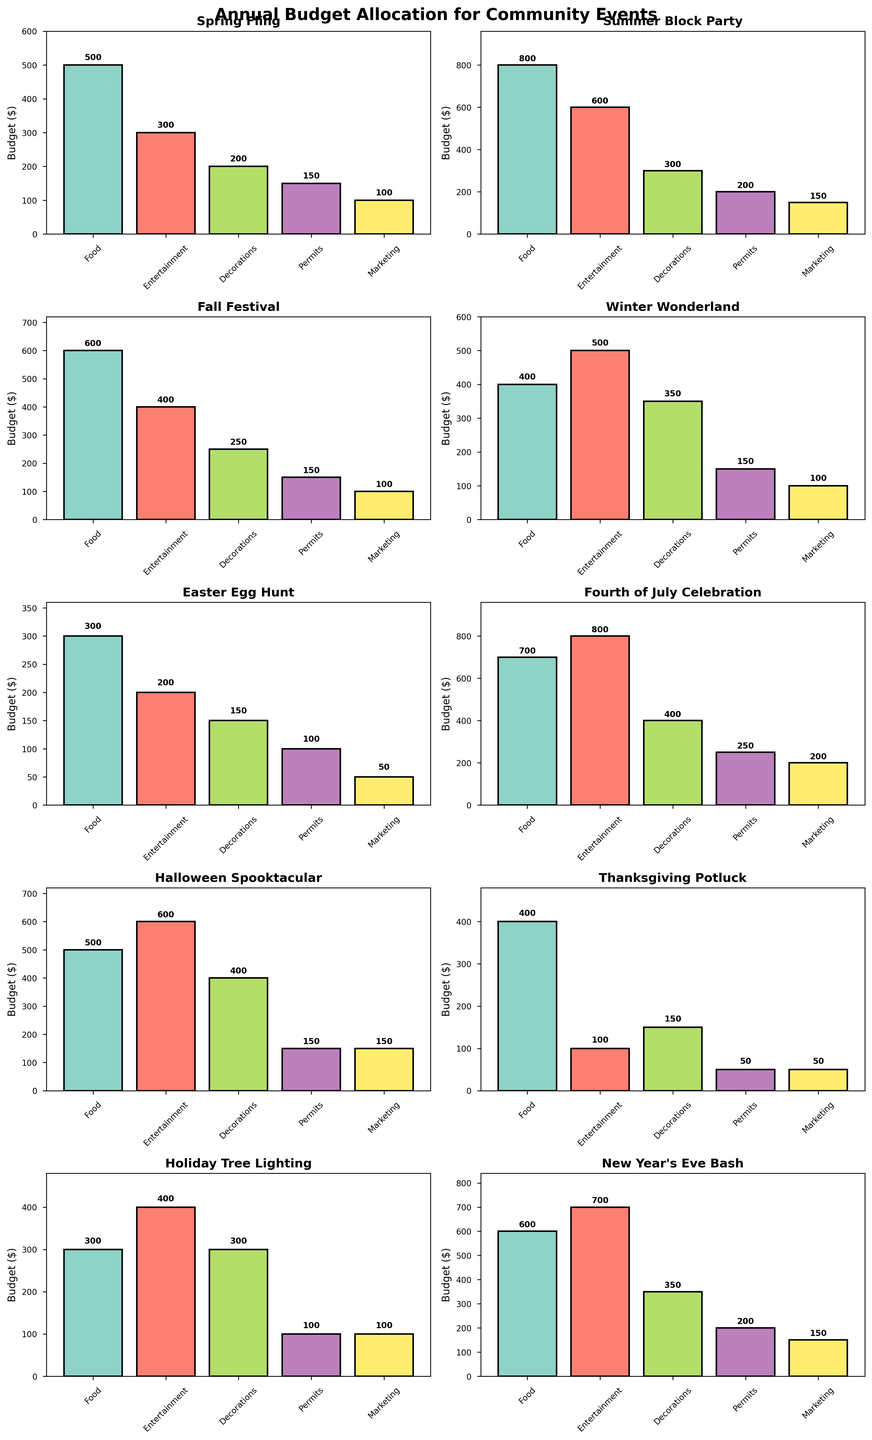What is the total budget allocated for the Easter Egg Hunt? Sum the budget across all categories (Food, Entertainment, Decorations, Permits, Marketing) for the Easter Egg Hunt: 300 + 200 + 150 + 100 + 50 = 800
Answer: 800 Which event has the highest budget allocation for Entertainment? Compare the Entertainment budget across all events and find the highest value. The Fourth of July Celebration has the highest budget for Entertainment with 800.
Answer: Fourth of July Celebration What is the average budget for Marketing across all events? Add up the Marketing budgets for all events and divide by the number of events. (100+150+100+100+50+200+150+50+100+150) / 10 = 1150 / 10 = 115
Answer: 115 How does the budget for Food in the Summer Block Party compare to the Fall Festival? The budget for Food in the Summer Block Party is 800 and in the Fall Festival is 600. 800 is greater than 600, so the Summer Block Party has a higher Food budget.
Answer: The Summer Block Party has a higher budget Which event has the smallest budget allocation for Permits? Compare the Permits budget across all events and find the smallest value. Thanksgiving Potluck has the smallest Permits budget of 50.
Answer: Thanksgiving Potluck What is the combined budget for Decorations in the Spring Fling and Winter Wonderland? Sum the budget for Decorations in Spring Fling (200) and Winter Wonderland (350). 200 + 350 = 550
Answer: 550 Which event has more budget allocated for Food than Entertainment? Compare the Food and Entertainment budgets for each event. The Summer Block Party (Food: 800, Entertainment: 600) and Fall Festival (Food: 600, Entertainment: 400) are such events.
Answer: Summer Block Party, Fall Festival What is the total budget allocated for the Summer Block Party and Fourth of July Celebration? Sum all budgets for both events. Summer Block Party: 800 + 600 + 300 + 200 + 150 = 2050, Fourth of July Celebration: 700 + 800 + 400 + 250 + 200 = 2350. Total: 2050 + 2350 = 4400
Answer: 4400 Which event’s budget allocation for Decorations is exactly 300? Identify the event from the bar chart with a Decorations budget of 300. Summer Block Party and Holiday Tree Lighting both have Decorations budgets of 300.
Answer: Summer Block Party, Holiday Tree Lighting What is the difference in the budget for Marketing between Halloween Spooktacular and New Year’s Eve Bash? Subtract the Marketing budget of New Year’s Eve Bash (150) from Halloween Spooktacular (150). 150 - 150 = 0
Answer: 0 